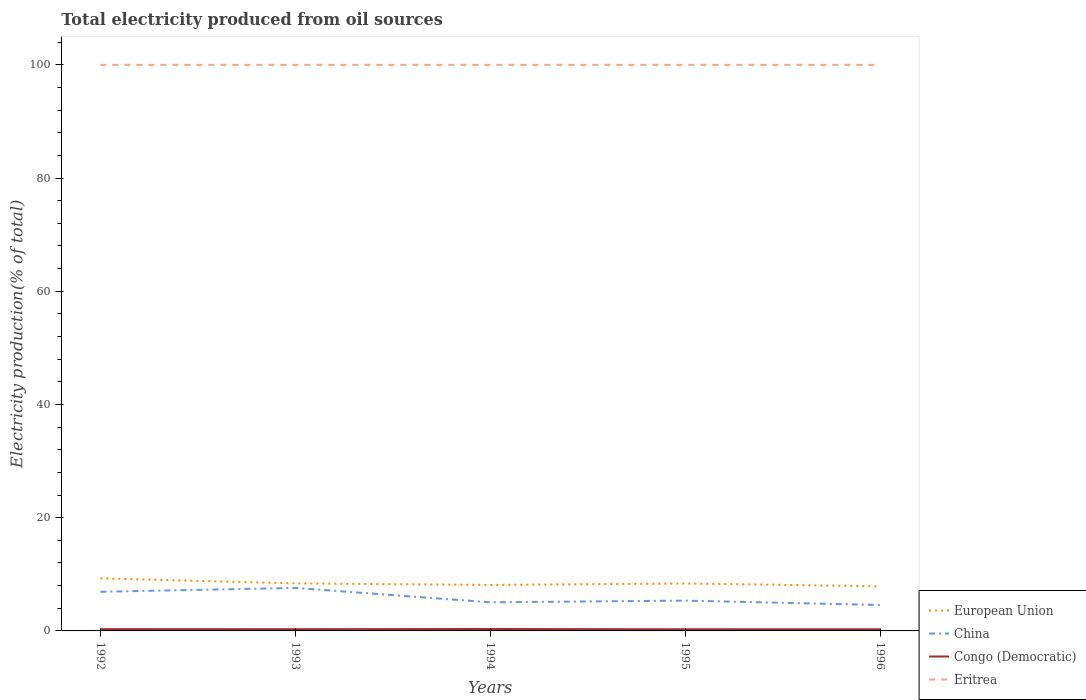In which year was the total electricity produced in Eritrea maximum?
Provide a short and direct response. 1992. What is the total total electricity produced in European Union in the graph?
Give a very brief answer. 0.9. What is the difference between the highest and the second highest total electricity produced in China?
Give a very brief answer. 3.02. How many lines are there?
Provide a short and direct response. 4. How many years are there in the graph?
Provide a short and direct response. 5. What is the difference between two consecutive major ticks on the Y-axis?
Your answer should be very brief. 20. Are the values on the major ticks of Y-axis written in scientific E-notation?
Offer a very short reply. No. Where does the legend appear in the graph?
Give a very brief answer. Bottom right. How are the legend labels stacked?
Your answer should be compact. Vertical. What is the title of the graph?
Offer a very short reply. Total electricity produced from oil sources. What is the Electricity production(% of total) of European Union in 1992?
Provide a short and direct response. 9.29. What is the Electricity production(% of total) of China in 1992?
Make the answer very short. 6.91. What is the Electricity production(% of total) in Congo (Democratic) in 1992?
Your answer should be compact. 0.31. What is the Electricity production(% of total) of Eritrea in 1992?
Provide a short and direct response. 100. What is the Electricity production(% of total) of European Union in 1993?
Provide a succinct answer. 8.4. What is the Electricity production(% of total) in China in 1993?
Make the answer very short. 7.6. What is the Electricity production(% of total) of Congo (Democratic) in 1993?
Provide a succinct answer. 0.31. What is the Electricity production(% of total) of Eritrea in 1993?
Offer a very short reply. 100. What is the Electricity production(% of total) in European Union in 1994?
Keep it short and to the point. 8.12. What is the Electricity production(% of total) of China in 1994?
Make the answer very short. 5.05. What is the Electricity production(% of total) in Congo (Democratic) in 1994?
Provide a short and direct response. 0.34. What is the Electricity production(% of total) in Eritrea in 1994?
Offer a very short reply. 100. What is the Electricity production(% of total) in European Union in 1995?
Your answer should be compact. 8.38. What is the Electricity production(% of total) in China in 1995?
Provide a succinct answer. 5.35. What is the Electricity production(% of total) in Congo (Democratic) in 1995?
Keep it short and to the point. 0.29. What is the Electricity production(% of total) in Eritrea in 1995?
Your answer should be very brief. 100. What is the Electricity production(% of total) in European Union in 1996?
Your answer should be compact. 7.88. What is the Electricity production(% of total) in China in 1996?
Ensure brevity in your answer.  4.58. What is the Electricity production(% of total) of Congo (Democratic) in 1996?
Keep it short and to the point. 0.29. What is the Electricity production(% of total) in Eritrea in 1996?
Provide a short and direct response. 100. Across all years, what is the maximum Electricity production(% of total) in European Union?
Provide a succinct answer. 9.29. Across all years, what is the maximum Electricity production(% of total) in China?
Keep it short and to the point. 7.6. Across all years, what is the maximum Electricity production(% of total) of Congo (Democratic)?
Your answer should be very brief. 0.34. Across all years, what is the maximum Electricity production(% of total) of Eritrea?
Offer a very short reply. 100. Across all years, what is the minimum Electricity production(% of total) in European Union?
Provide a succinct answer. 7.88. Across all years, what is the minimum Electricity production(% of total) of China?
Offer a terse response. 4.58. Across all years, what is the minimum Electricity production(% of total) in Congo (Democratic)?
Give a very brief answer. 0.29. What is the total Electricity production(% of total) in European Union in the graph?
Your response must be concise. 42.06. What is the total Electricity production(% of total) in China in the graph?
Your answer should be compact. 29.5. What is the total Electricity production(% of total) in Congo (Democratic) in the graph?
Ensure brevity in your answer.  1.54. What is the total Electricity production(% of total) in Eritrea in the graph?
Offer a terse response. 500. What is the difference between the Electricity production(% of total) of European Union in 1992 and that in 1993?
Keep it short and to the point. 0.89. What is the difference between the Electricity production(% of total) in China in 1992 and that in 1993?
Make the answer very short. -0.69. What is the difference between the Electricity production(% of total) of Congo (Democratic) in 1992 and that in 1993?
Give a very brief answer. 0.01. What is the difference between the Electricity production(% of total) in Eritrea in 1992 and that in 1993?
Your answer should be compact. 0. What is the difference between the Electricity production(% of total) in European Union in 1992 and that in 1994?
Make the answer very short. 1.17. What is the difference between the Electricity production(% of total) in China in 1992 and that in 1994?
Offer a very short reply. 1.86. What is the difference between the Electricity production(% of total) in Congo (Democratic) in 1992 and that in 1994?
Offer a very short reply. -0.03. What is the difference between the Electricity production(% of total) in European Union in 1992 and that in 1995?
Keep it short and to the point. 0.9. What is the difference between the Electricity production(% of total) of China in 1992 and that in 1995?
Make the answer very short. 1.56. What is the difference between the Electricity production(% of total) in Congo (Democratic) in 1992 and that in 1995?
Ensure brevity in your answer.  0.02. What is the difference between the Electricity production(% of total) in European Union in 1992 and that in 1996?
Give a very brief answer. 1.41. What is the difference between the Electricity production(% of total) of China in 1992 and that in 1996?
Ensure brevity in your answer.  2.33. What is the difference between the Electricity production(% of total) in Congo (Democratic) in 1992 and that in 1996?
Ensure brevity in your answer.  0.02. What is the difference between the Electricity production(% of total) of Eritrea in 1992 and that in 1996?
Provide a succinct answer. 0. What is the difference between the Electricity production(% of total) of European Union in 1993 and that in 1994?
Offer a very short reply. 0.28. What is the difference between the Electricity production(% of total) in China in 1993 and that in 1994?
Offer a terse response. 2.54. What is the difference between the Electricity production(% of total) of Congo (Democratic) in 1993 and that in 1994?
Your answer should be very brief. -0.03. What is the difference between the Electricity production(% of total) of Eritrea in 1993 and that in 1994?
Offer a very short reply. 0. What is the difference between the Electricity production(% of total) of European Union in 1993 and that in 1995?
Provide a short and direct response. 0.01. What is the difference between the Electricity production(% of total) in China in 1993 and that in 1995?
Make the answer very short. 2.24. What is the difference between the Electricity production(% of total) of Congo (Democratic) in 1993 and that in 1995?
Make the answer very short. 0.02. What is the difference between the Electricity production(% of total) of Eritrea in 1993 and that in 1995?
Provide a succinct answer. 0. What is the difference between the Electricity production(% of total) of European Union in 1993 and that in 1996?
Offer a very short reply. 0.52. What is the difference between the Electricity production(% of total) in China in 1993 and that in 1996?
Offer a very short reply. 3.02. What is the difference between the Electricity production(% of total) in Congo (Democratic) in 1993 and that in 1996?
Keep it short and to the point. 0.01. What is the difference between the Electricity production(% of total) of European Union in 1994 and that in 1995?
Provide a succinct answer. -0.27. What is the difference between the Electricity production(% of total) in China in 1994 and that in 1995?
Your response must be concise. -0.3. What is the difference between the Electricity production(% of total) in Congo (Democratic) in 1994 and that in 1995?
Keep it short and to the point. 0.05. What is the difference between the Electricity production(% of total) in European Union in 1994 and that in 1996?
Offer a very short reply. 0.24. What is the difference between the Electricity production(% of total) of China in 1994 and that in 1996?
Keep it short and to the point. 0.47. What is the difference between the Electricity production(% of total) of Congo (Democratic) in 1994 and that in 1996?
Offer a very short reply. 0.04. What is the difference between the Electricity production(% of total) of Eritrea in 1994 and that in 1996?
Provide a succinct answer. 0. What is the difference between the Electricity production(% of total) of European Union in 1995 and that in 1996?
Your answer should be very brief. 0.5. What is the difference between the Electricity production(% of total) of China in 1995 and that in 1996?
Your answer should be compact. 0.77. What is the difference between the Electricity production(% of total) of Congo (Democratic) in 1995 and that in 1996?
Give a very brief answer. -0. What is the difference between the Electricity production(% of total) in Eritrea in 1995 and that in 1996?
Offer a terse response. 0. What is the difference between the Electricity production(% of total) of European Union in 1992 and the Electricity production(% of total) of China in 1993?
Offer a very short reply. 1.69. What is the difference between the Electricity production(% of total) in European Union in 1992 and the Electricity production(% of total) in Congo (Democratic) in 1993?
Your response must be concise. 8.98. What is the difference between the Electricity production(% of total) in European Union in 1992 and the Electricity production(% of total) in Eritrea in 1993?
Make the answer very short. -90.71. What is the difference between the Electricity production(% of total) of China in 1992 and the Electricity production(% of total) of Congo (Democratic) in 1993?
Your answer should be very brief. 6.61. What is the difference between the Electricity production(% of total) of China in 1992 and the Electricity production(% of total) of Eritrea in 1993?
Ensure brevity in your answer.  -93.09. What is the difference between the Electricity production(% of total) in Congo (Democratic) in 1992 and the Electricity production(% of total) in Eritrea in 1993?
Provide a succinct answer. -99.69. What is the difference between the Electricity production(% of total) in European Union in 1992 and the Electricity production(% of total) in China in 1994?
Your answer should be compact. 4.23. What is the difference between the Electricity production(% of total) in European Union in 1992 and the Electricity production(% of total) in Congo (Democratic) in 1994?
Ensure brevity in your answer.  8.95. What is the difference between the Electricity production(% of total) of European Union in 1992 and the Electricity production(% of total) of Eritrea in 1994?
Your response must be concise. -90.71. What is the difference between the Electricity production(% of total) of China in 1992 and the Electricity production(% of total) of Congo (Democratic) in 1994?
Offer a very short reply. 6.57. What is the difference between the Electricity production(% of total) of China in 1992 and the Electricity production(% of total) of Eritrea in 1994?
Provide a succinct answer. -93.09. What is the difference between the Electricity production(% of total) of Congo (Democratic) in 1992 and the Electricity production(% of total) of Eritrea in 1994?
Your answer should be very brief. -99.69. What is the difference between the Electricity production(% of total) of European Union in 1992 and the Electricity production(% of total) of China in 1995?
Keep it short and to the point. 3.93. What is the difference between the Electricity production(% of total) of European Union in 1992 and the Electricity production(% of total) of Congo (Democratic) in 1995?
Give a very brief answer. 8.99. What is the difference between the Electricity production(% of total) in European Union in 1992 and the Electricity production(% of total) in Eritrea in 1995?
Ensure brevity in your answer.  -90.71. What is the difference between the Electricity production(% of total) in China in 1992 and the Electricity production(% of total) in Congo (Democratic) in 1995?
Your answer should be very brief. 6.62. What is the difference between the Electricity production(% of total) of China in 1992 and the Electricity production(% of total) of Eritrea in 1995?
Provide a short and direct response. -93.09. What is the difference between the Electricity production(% of total) in Congo (Democratic) in 1992 and the Electricity production(% of total) in Eritrea in 1995?
Offer a terse response. -99.69. What is the difference between the Electricity production(% of total) in European Union in 1992 and the Electricity production(% of total) in China in 1996?
Provide a succinct answer. 4.71. What is the difference between the Electricity production(% of total) in European Union in 1992 and the Electricity production(% of total) in Congo (Democratic) in 1996?
Ensure brevity in your answer.  8.99. What is the difference between the Electricity production(% of total) in European Union in 1992 and the Electricity production(% of total) in Eritrea in 1996?
Make the answer very short. -90.71. What is the difference between the Electricity production(% of total) of China in 1992 and the Electricity production(% of total) of Congo (Democratic) in 1996?
Make the answer very short. 6.62. What is the difference between the Electricity production(% of total) of China in 1992 and the Electricity production(% of total) of Eritrea in 1996?
Your answer should be very brief. -93.09. What is the difference between the Electricity production(% of total) in Congo (Democratic) in 1992 and the Electricity production(% of total) in Eritrea in 1996?
Provide a succinct answer. -99.69. What is the difference between the Electricity production(% of total) in European Union in 1993 and the Electricity production(% of total) in China in 1994?
Your response must be concise. 3.34. What is the difference between the Electricity production(% of total) in European Union in 1993 and the Electricity production(% of total) in Congo (Democratic) in 1994?
Keep it short and to the point. 8.06. What is the difference between the Electricity production(% of total) of European Union in 1993 and the Electricity production(% of total) of Eritrea in 1994?
Ensure brevity in your answer.  -91.6. What is the difference between the Electricity production(% of total) of China in 1993 and the Electricity production(% of total) of Congo (Democratic) in 1994?
Your answer should be very brief. 7.26. What is the difference between the Electricity production(% of total) in China in 1993 and the Electricity production(% of total) in Eritrea in 1994?
Provide a short and direct response. -92.4. What is the difference between the Electricity production(% of total) in Congo (Democratic) in 1993 and the Electricity production(% of total) in Eritrea in 1994?
Offer a very short reply. -99.69. What is the difference between the Electricity production(% of total) of European Union in 1993 and the Electricity production(% of total) of China in 1995?
Provide a succinct answer. 3.04. What is the difference between the Electricity production(% of total) of European Union in 1993 and the Electricity production(% of total) of Congo (Democratic) in 1995?
Offer a terse response. 8.11. What is the difference between the Electricity production(% of total) in European Union in 1993 and the Electricity production(% of total) in Eritrea in 1995?
Your answer should be very brief. -91.6. What is the difference between the Electricity production(% of total) in China in 1993 and the Electricity production(% of total) in Congo (Democratic) in 1995?
Offer a terse response. 7.31. What is the difference between the Electricity production(% of total) in China in 1993 and the Electricity production(% of total) in Eritrea in 1995?
Provide a short and direct response. -92.4. What is the difference between the Electricity production(% of total) in Congo (Democratic) in 1993 and the Electricity production(% of total) in Eritrea in 1995?
Provide a short and direct response. -99.69. What is the difference between the Electricity production(% of total) of European Union in 1993 and the Electricity production(% of total) of China in 1996?
Your response must be concise. 3.82. What is the difference between the Electricity production(% of total) in European Union in 1993 and the Electricity production(% of total) in Congo (Democratic) in 1996?
Offer a terse response. 8.1. What is the difference between the Electricity production(% of total) in European Union in 1993 and the Electricity production(% of total) in Eritrea in 1996?
Make the answer very short. -91.6. What is the difference between the Electricity production(% of total) of China in 1993 and the Electricity production(% of total) of Congo (Democratic) in 1996?
Offer a very short reply. 7.3. What is the difference between the Electricity production(% of total) in China in 1993 and the Electricity production(% of total) in Eritrea in 1996?
Provide a succinct answer. -92.4. What is the difference between the Electricity production(% of total) of Congo (Democratic) in 1993 and the Electricity production(% of total) of Eritrea in 1996?
Provide a short and direct response. -99.69. What is the difference between the Electricity production(% of total) in European Union in 1994 and the Electricity production(% of total) in China in 1995?
Your answer should be compact. 2.76. What is the difference between the Electricity production(% of total) of European Union in 1994 and the Electricity production(% of total) of Congo (Democratic) in 1995?
Your response must be concise. 7.82. What is the difference between the Electricity production(% of total) in European Union in 1994 and the Electricity production(% of total) in Eritrea in 1995?
Offer a terse response. -91.88. What is the difference between the Electricity production(% of total) of China in 1994 and the Electricity production(% of total) of Congo (Democratic) in 1995?
Keep it short and to the point. 4.76. What is the difference between the Electricity production(% of total) in China in 1994 and the Electricity production(% of total) in Eritrea in 1995?
Ensure brevity in your answer.  -94.95. What is the difference between the Electricity production(% of total) in Congo (Democratic) in 1994 and the Electricity production(% of total) in Eritrea in 1995?
Offer a very short reply. -99.66. What is the difference between the Electricity production(% of total) in European Union in 1994 and the Electricity production(% of total) in China in 1996?
Your answer should be compact. 3.54. What is the difference between the Electricity production(% of total) of European Union in 1994 and the Electricity production(% of total) of Congo (Democratic) in 1996?
Give a very brief answer. 7.82. What is the difference between the Electricity production(% of total) in European Union in 1994 and the Electricity production(% of total) in Eritrea in 1996?
Offer a terse response. -91.88. What is the difference between the Electricity production(% of total) in China in 1994 and the Electricity production(% of total) in Congo (Democratic) in 1996?
Provide a short and direct response. 4.76. What is the difference between the Electricity production(% of total) in China in 1994 and the Electricity production(% of total) in Eritrea in 1996?
Make the answer very short. -94.95. What is the difference between the Electricity production(% of total) of Congo (Democratic) in 1994 and the Electricity production(% of total) of Eritrea in 1996?
Ensure brevity in your answer.  -99.66. What is the difference between the Electricity production(% of total) in European Union in 1995 and the Electricity production(% of total) in China in 1996?
Your answer should be very brief. 3.8. What is the difference between the Electricity production(% of total) in European Union in 1995 and the Electricity production(% of total) in Congo (Democratic) in 1996?
Offer a very short reply. 8.09. What is the difference between the Electricity production(% of total) of European Union in 1995 and the Electricity production(% of total) of Eritrea in 1996?
Your response must be concise. -91.62. What is the difference between the Electricity production(% of total) of China in 1995 and the Electricity production(% of total) of Congo (Democratic) in 1996?
Offer a very short reply. 5.06. What is the difference between the Electricity production(% of total) of China in 1995 and the Electricity production(% of total) of Eritrea in 1996?
Offer a terse response. -94.65. What is the difference between the Electricity production(% of total) of Congo (Democratic) in 1995 and the Electricity production(% of total) of Eritrea in 1996?
Your answer should be very brief. -99.71. What is the average Electricity production(% of total) in European Union per year?
Provide a succinct answer. 8.41. What is the average Electricity production(% of total) of China per year?
Offer a very short reply. 5.9. What is the average Electricity production(% of total) in Congo (Democratic) per year?
Your response must be concise. 0.31. In the year 1992, what is the difference between the Electricity production(% of total) of European Union and Electricity production(% of total) of China?
Give a very brief answer. 2.37. In the year 1992, what is the difference between the Electricity production(% of total) of European Union and Electricity production(% of total) of Congo (Democratic)?
Offer a terse response. 8.97. In the year 1992, what is the difference between the Electricity production(% of total) in European Union and Electricity production(% of total) in Eritrea?
Give a very brief answer. -90.71. In the year 1992, what is the difference between the Electricity production(% of total) of China and Electricity production(% of total) of Congo (Democratic)?
Keep it short and to the point. 6.6. In the year 1992, what is the difference between the Electricity production(% of total) of China and Electricity production(% of total) of Eritrea?
Keep it short and to the point. -93.09. In the year 1992, what is the difference between the Electricity production(% of total) of Congo (Democratic) and Electricity production(% of total) of Eritrea?
Make the answer very short. -99.69. In the year 1993, what is the difference between the Electricity production(% of total) in European Union and Electricity production(% of total) in China?
Your answer should be compact. 0.8. In the year 1993, what is the difference between the Electricity production(% of total) in European Union and Electricity production(% of total) in Congo (Democratic)?
Offer a terse response. 8.09. In the year 1993, what is the difference between the Electricity production(% of total) of European Union and Electricity production(% of total) of Eritrea?
Make the answer very short. -91.6. In the year 1993, what is the difference between the Electricity production(% of total) of China and Electricity production(% of total) of Congo (Democratic)?
Ensure brevity in your answer.  7.29. In the year 1993, what is the difference between the Electricity production(% of total) of China and Electricity production(% of total) of Eritrea?
Keep it short and to the point. -92.4. In the year 1993, what is the difference between the Electricity production(% of total) in Congo (Democratic) and Electricity production(% of total) in Eritrea?
Give a very brief answer. -99.69. In the year 1994, what is the difference between the Electricity production(% of total) of European Union and Electricity production(% of total) of China?
Offer a terse response. 3.06. In the year 1994, what is the difference between the Electricity production(% of total) of European Union and Electricity production(% of total) of Congo (Democratic)?
Your answer should be compact. 7.78. In the year 1994, what is the difference between the Electricity production(% of total) of European Union and Electricity production(% of total) of Eritrea?
Keep it short and to the point. -91.88. In the year 1994, what is the difference between the Electricity production(% of total) of China and Electricity production(% of total) of Congo (Democratic)?
Offer a terse response. 4.71. In the year 1994, what is the difference between the Electricity production(% of total) of China and Electricity production(% of total) of Eritrea?
Your answer should be compact. -94.95. In the year 1994, what is the difference between the Electricity production(% of total) in Congo (Democratic) and Electricity production(% of total) in Eritrea?
Your response must be concise. -99.66. In the year 1995, what is the difference between the Electricity production(% of total) of European Union and Electricity production(% of total) of China?
Offer a very short reply. 3.03. In the year 1995, what is the difference between the Electricity production(% of total) in European Union and Electricity production(% of total) in Congo (Democratic)?
Your answer should be compact. 8.09. In the year 1995, what is the difference between the Electricity production(% of total) of European Union and Electricity production(% of total) of Eritrea?
Provide a succinct answer. -91.62. In the year 1995, what is the difference between the Electricity production(% of total) in China and Electricity production(% of total) in Congo (Democratic)?
Your answer should be compact. 5.06. In the year 1995, what is the difference between the Electricity production(% of total) in China and Electricity production(% of total) in Eritrea?
Provide a short and direct response. -94.65. In the year 1995, what is the difference between the Electricity production(% of total) in Congo (Democratic) and Electricity production(% of total) in Eritrea?
Your answer should be compact. -99.71. In the year 1996, what is the difference between the Electricity production(% of total) of European Union and Electricity production(% of total) of China?
Offer a terse response. 3.3. In the year 1996, what is the difference between the Electricity production(% of total) of European Union and Electricity production(% of total) of Congo (Democratic)?
Give a very brief answer. 7.58. In the year 1996, what is the difference between the Electricity production(% of total) in European Union and Electricity production(% of total) in Eritrea?
Offer a very short reply. -92.12. In the year 1996, what is the difference between the Electricity production(% of total) of China and Electricity production(% of total) of Congo (Democratic)?
Keep it short and to the point. 4.29. In the year 1996, what is the difference between the Electricity production(% of total) in China and Electricity production(% of total) in Eritrea?
Your answer should be very brief. -95.42. In the year 1996, what is the difference between the Electricity production(% of total) of Congo (Democratic) and Electricity production(% of total) of Eritrea?
Your answer should be very brief. -99.71. What is the ratio of the Electricity production(% of total) of European Union in 1992 to that in 1993?
Provide a succinct answer. 1.11. What is the ratio of the Electricity production(% of total) of China in 1992 to that in 1993?
Your answer should be very brief. 0.91. What is the ratio of the Electricity production(% of total) of Congo (Democratic) in 1992 to that in 1993?
Your answer should be compact. 1.02. What is the ratio of the Electricity production(% of total) in Eritrea in 1992 to that in 1993?
Ensure brevity in your answer.  1. What is the ratio of the Electricity production(% of total) of European Union in 1992 to that in 1994?
Make the answer very short. 1.14. What is the ratio of the Electricity production(% of total) of China in 1992 to that in 1994?
Your answer should be very brief. 1.37. What is the ratio of the Electricity production(% of total) of Congo (Democratic) in 1992 to that in 1994?
Make the answer very short. 0.92. What is the ratio of the Electricity production(% of total) in European Union in 1992 to that in 1995?
Your answer should be compact. 1.11. What is the ratio of the Electricity production(% of total) of China in 1992 to that in 1995?
Make the answer very short. 1.29. What is the ratio of the Electricity production(% of total) in Congo (Democratic) in 1992 to that in 1995?
Keep it short and to the point. 1.07. What is the ratio of the Electricity production(% of total) of European Union in 1992 to that in 1996?
Your response must be concise. 1.18. What is the ratio of the Electricity production(% of total) of China in 1992 to that in 1996?
Your response must be concise. 1.51. What is the ratio of the Electricity production(% of total) of Congo (Democratic) in 1992 to that in 1996?
Give a very brief answer. 1.06. What is the ratio of the Electricity production(% of total) in European Union in 1993 to that in 1994?
Make the answer very short. 1.03. What is the ratio of the Electricity production(% of total) in China in 1993 to that in 1994?
Your answer should be very brief. 1.5. What is the ratio of the Electricity production(% of total) of Congo (Democratic) in 1993 to that in 1994?
Your answer should be compact. 0.9. What is the ratio of the Electricity production(% of total) of Eritrea in 1993 to that in 1994?
Offer a terse response. 1. What is the ratio of the Electricity production(% of total) in China in 1993 to that in 1995?
Your answer should be very brief. 1.42. What is the ratio of the Electricity production(% of total) in Congo (Democratic) in 1993 to that in 1995?
Your response must be concise. 1.05. What is the ratio of the Electricity production(% of total) in European Union in 1993 to that in 1996?
Provide a succinct answer. 1.07. What is the ratio of the Electricity production(% of total) of China in 1993 to that in 1996?
Provide a succinct answer. 1.66. What is the ratio of the Electricity production(% of total) in Congo (Democratic) in 1993 to that in 1996?
Give a very brief answer. 1.04. What is the ratio of the Electricity production(% of total) in European Union in 1994 to that in 1995?
Provide a short and direct response. 0.97. What is the ratio of the Electricity production(% of total) of China in 1994 to that in 1995?
Keep it short and to the point. 0.94. What is the ratio of the Electricity production(% of total) of Congo (Democratic) in 1994 to that in 1995?
Provide a short and direct response. 1.16. What is the ratio of the Electricity production(% of total) of Eritrea in 1994 to that in 1995?
Offer a very short reply. 1. What is the ratio of the Electricity production(% of total) of European Union in 1994 to that in 1996?
Provide a short and direct response. 1.03. What is the ratio of the Electricity production(% of total) in China in 1994 to that in 1996?
Offer a terse response. 1.1. What is the ratio of the Electricity production(% of total) in Congo (Democratic) in 1994 to that in 1996?
Make the answer very short. 1.15. What is the ratio of the Electricity production(% of total) of Eritrea in 1994 to that in 1996?
Give a very brief answer. 1. What is the ratio of the Electricity production(% of total) in European Union in 1995 to that in 1996?
Make the answer very short. 1.06. What is the ratio of the Electricity production(% of total) of China in 1995 to that in 1996?
Make the answer very short. 1.17. What is the ratio of the Electricity production(% of total) in Congo (Democratic) in 1995 to that in 1996?
Provide a succinct answer. 0.99. What is the ratio of the Electricity production(% of total) in Eritrea in 1995 to that in 1996?
Your response must be concise. 1. What is the difference between the highest and the second highest Electricity production(% of total) of European Union?
Provide a succinct answer. 0.89. What is the difference between the highest and the second highest Electricity production(% of total) of China?
Offer a terse response. 0.69. What is the difference between the highest and the second highest Electricity production(% of total) in Congo (Democratic)?
Your response must be concise. 0.03. What is the difference between the highest and the lowest Electricity production(% of total) in European Union?
Keep it short and to the point. 1.41. What is the difference between the highest and the lowest Electricity production(% of total) of China?
Your response must be concise. 3.02. What is the difference between the highest and the lowest Electricity production(% of total) in Congo (Democratic)?
Offer a very short reply. 0.05. 